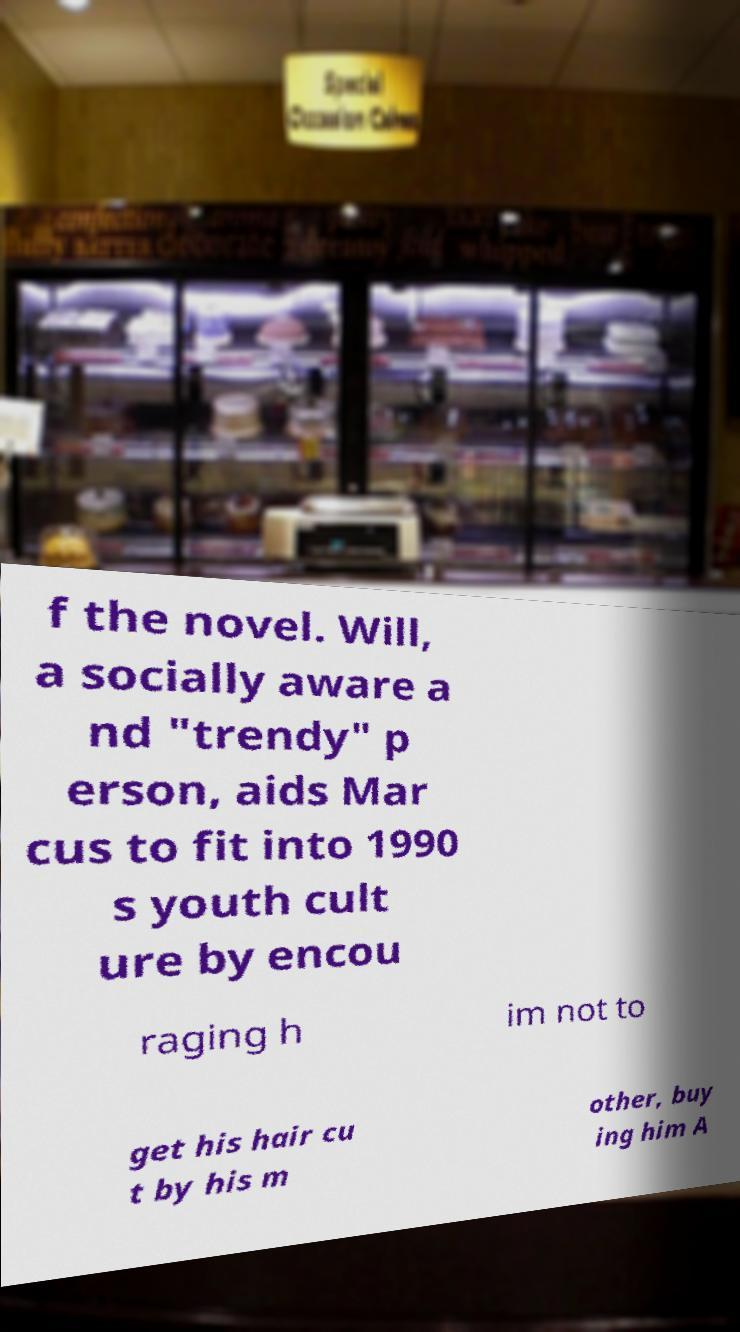Please identify and transcribe the text found in this image. f the novel. Will, a socially aware a nd "trendy" p erson, aids Mar cus to fit into 1990 s youth cult ure by encou raging h im not to get his hair cu t by his m other, buy ing him A 